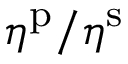<formula> <loc_0><loc_0><loc_500><loc_500>\eta ^ { p } / \eta ^ { s }</formula> 